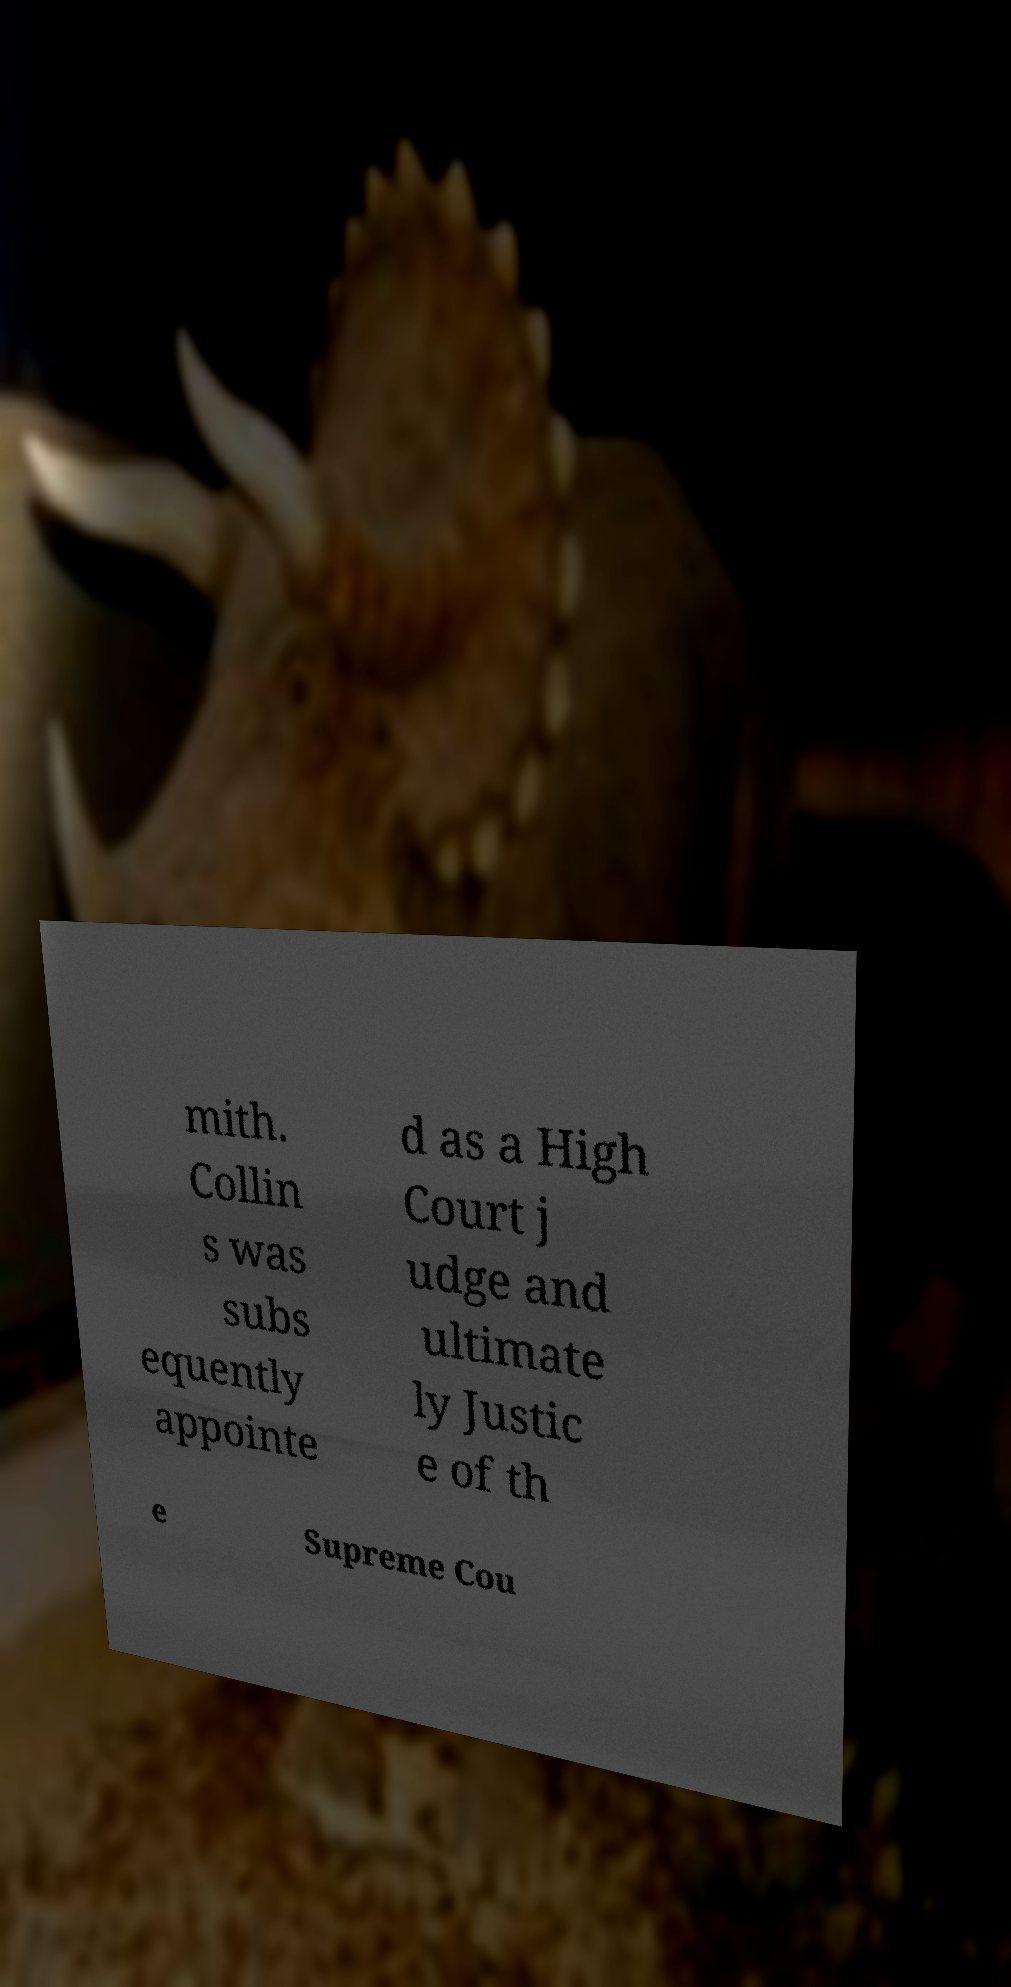Please read and relay the text visible in this image. What does it say? mith. Collin s was subs equently appointe d as a High Court j udge and ultimate ly Justic e of th e Supreme Cou 